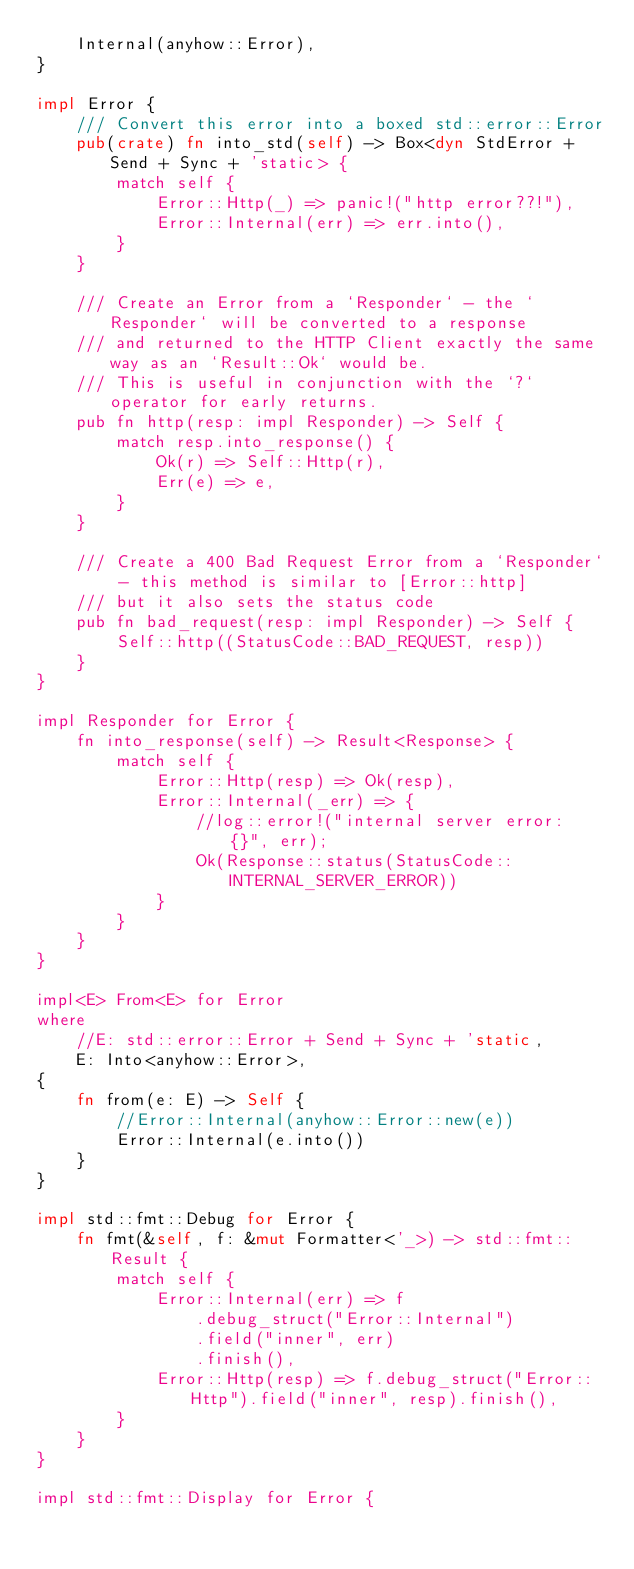<code> <loc_0><loc_0><loc_500><loc_500><_Rust_>    Internal(anyhow::Error),
}

impl Error {
    /// Convert this error into a boxed std::error::Error
    pub(crate) fn into_std(self) -> Box<dyn StdError + Send + Sync + 'static> {
        match self {
            Error::Http(_) => panic!("http error??!"),
            Error::Internal(err) => err.into(),
        }
    }

    /// Create an Error from a `Responder` - the `Responder` will be converted to a response
    /// and returned to the HTTP Client exactly the same way as an `Result::Ok` would be.
    /// This is useful in conjunction with the `?` operator for early returns.
    pub fn http(resp: impl Responder) -> Self {
        match resp.into_response() {
            Ok(r) => Self::Http(r),
            Err(e) => e,
        }
    }

    /// Create a 400 Bad Request Error from a `Responder` - this method is similar to [Error::http]
    /// but it also sets the status code
    pub fn bad_request(resp: impl Responder) -> Self {
        Self::http((StatusCode::BAD_REQUEST, resp))
    }
}

impl Responder for Error {
    fn into_response(self) -> Result<Response> {
        match self {
            Error::Http(resp) => Ok(resp),
            Error::Internal(_err) => {
                //log::error!("internal server error: {}", err);
                Ok(Response::status(StatusCode::INTERNAL_SERVER_ERROR))
            }
        }
    }
}

impl<E> From<E> for Error
where
    //E: std::error::Error + Send + Sync + 'static,
    E: Into<anyhow::Error>,
{
    fn from(e: E) -> Self {
        //Error::Internal(anyhow::Error::new(e))
        Error::Internal(e.into())
    }
}

impl std::fmt::Debug for Error {
    fn fmt(&self, f: &mut Formatter<'_>) -> std::fmt::Result {
        match self {
            Error::Internal(err) => f
                .debug_struct("Error::Internal")
                .field("inner", err)
                .finish(),
            Error::Http(resp) => f.debug_struct("Error::Http").field("inner", resp).finish(),
        }
    }
}

impl std::fmt::Display for Error {</code> 